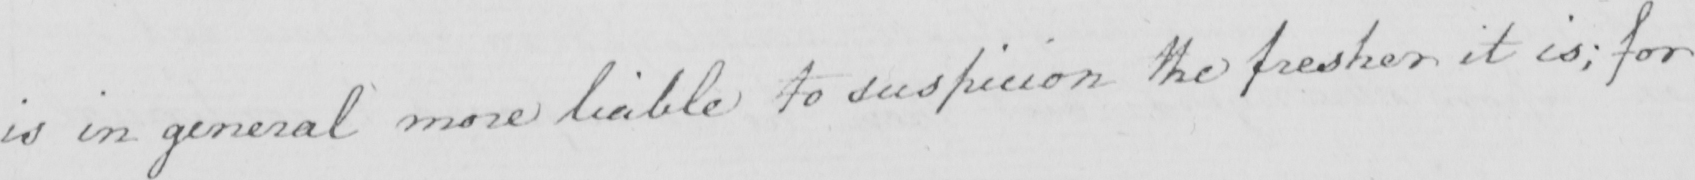What text is written in this handwritten line? is in general more liable to suspicion the fresher it is ; for 